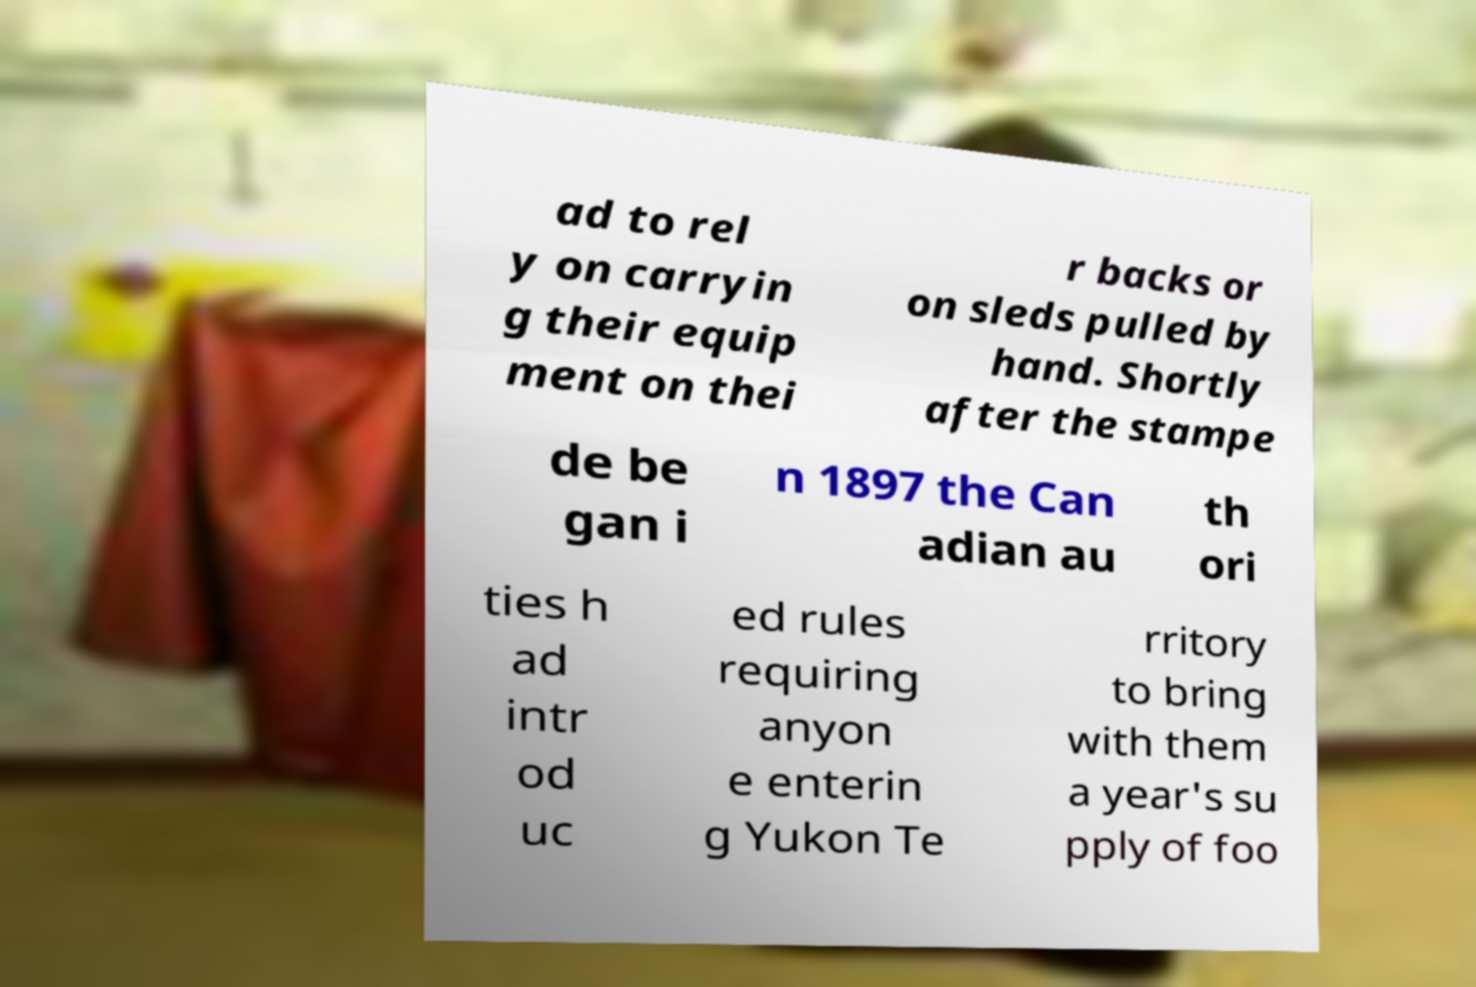There's text embedded in this image that I need extracted. Can you transcribe it verbatim? ad to rel y on carryin g their equip ment on thei r backs or on sleds pulled by hand. Shortly after the stampe de be gan i n 1897 the Can adian au th ori ties h ad intr od uc ed rules requiring anyon e enterin g Yukon Te rritory to bring with them a year's su pply of foo 